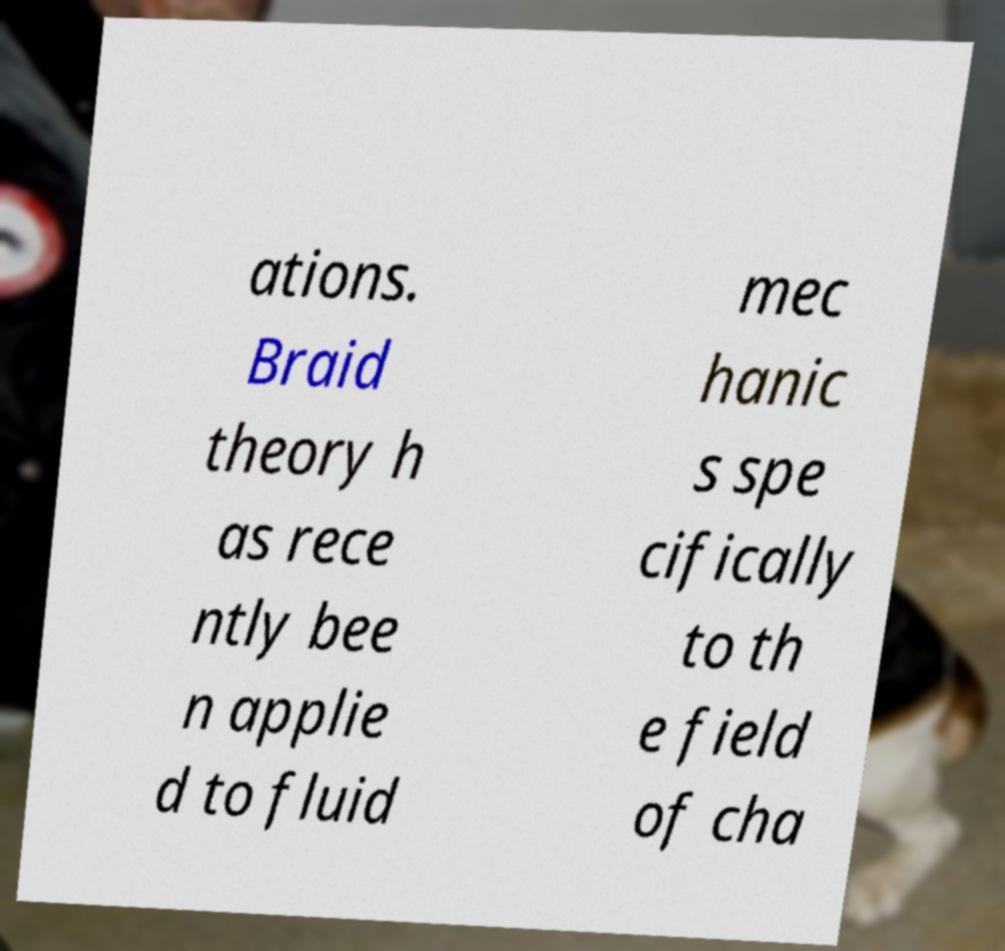Can you accurately transcribe the text from the provided image for me? ations. Braid theory h as rece ntly bee n applie d to fluid mec hanic s spe cifically to th e field of cha 